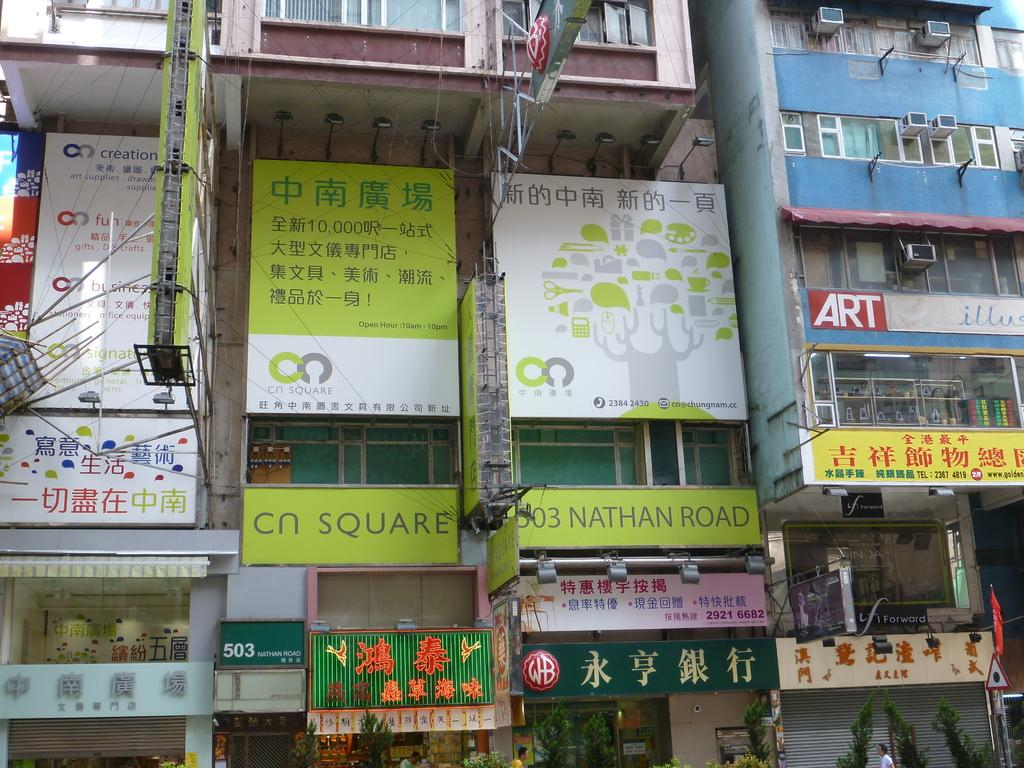<image>
Offer a succinct explanation of the picture presented. a display of all shops at address 503 Nathan Road 